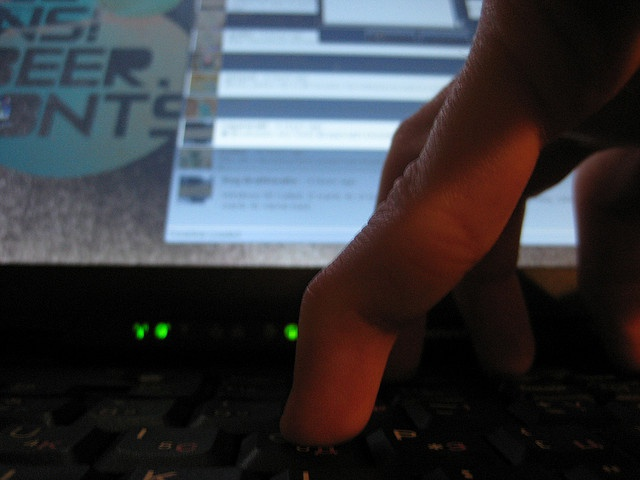Describe the objects in this image and their specific colors. I can see laptop in black, gray, lightblue, and blue tones, people in gray, black, maroon, and darkgray tones, and keyboard in black, maroon, and gray tones in this image. 